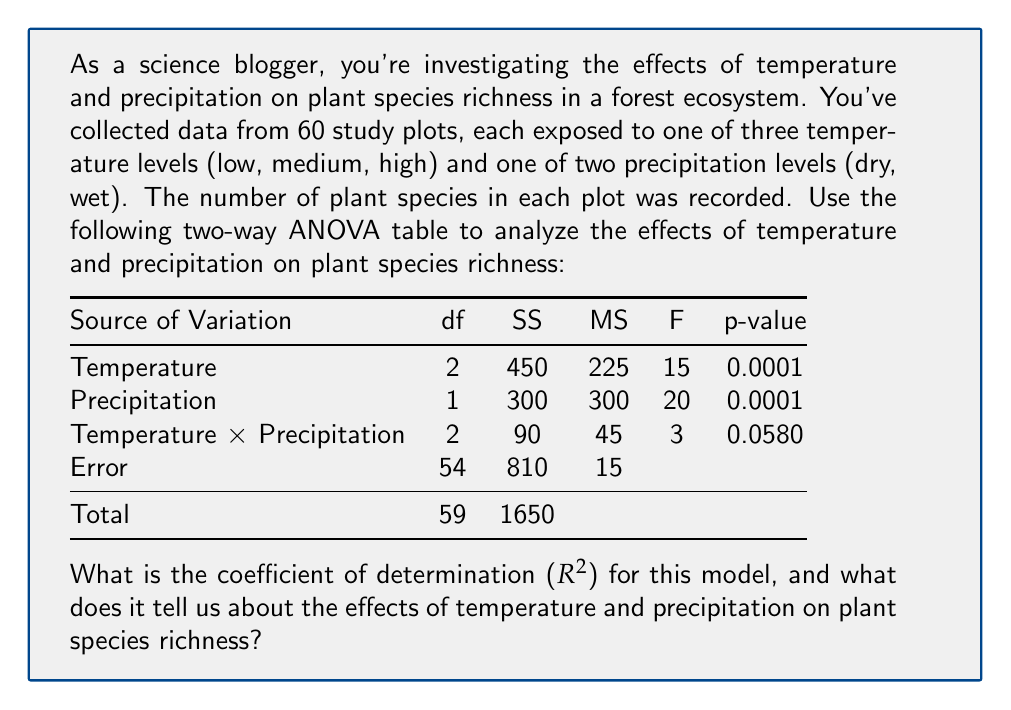Show me your answer to this math problem. To calculate the coefficient of determination (R²), we need to follow these steps:

1. Calculate the total sum of squares (SST):
   SST = 1650 (given in the "Total" row)

2. Calculate the sum of squares for the error (SSE):
   SSE = 810 (given in the "Error" row)

3. Calculate the sum of squares for the model (SSM):
   SSM = SST - SSE = 1650 - 810 = 840

4. Calculate R² using the formula:
   $$R^2 = \frac{SSM}{SST} = \frac{840}{1650} = 0.5091$$

5. Convert to percentage:
   0.5091 * 100 = 50.91%

Interpretation:
The R² value of 0.5091 (or 50.91%) indicates that approximately 51% of the variability in plant species richness can be explained by temperature, precipitation, and their interaction in this model. This suggests that these environmental factors have a moderate effect on biodiversity in the forest ecosystem.

Additional insights from the ANOVA table:
1. Both temperature (p = 0.0001) and precipitation (p = 0.0001) have significant main effects on plant species richness.
2. The interaction between temperature and precipitation (p = 0.0580) is not significant at the 0.05 level, but it may be worth considering as it's close to the threshold.
3. The remaining 49% of variability is due to factors not accounted for in this model or random variation.
Answer: R² = 0.5091 (51% of variability explained by temperature and precipitation) 